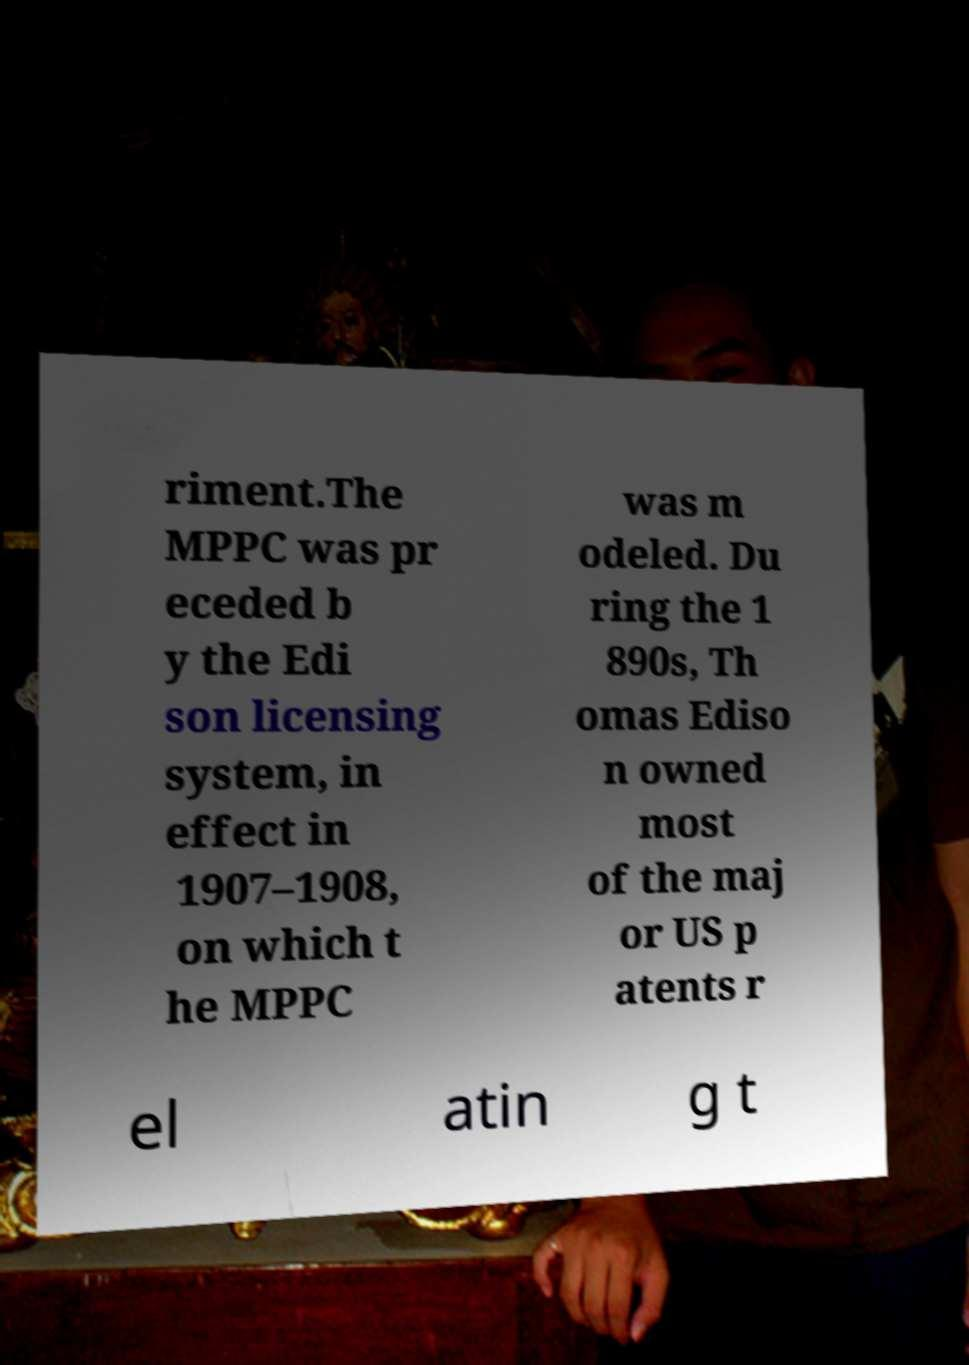What messages or text are displayed in this image? I need them in a readable, typed format. riment.The MPPC was pr eceded b y the Edi son licensing system, in effect in 1907–1908, on which t he MPPC was m odeled. Du ring the 1 890s, Th omas Ediso n owned most of the maj or US p atents r el atin g t 